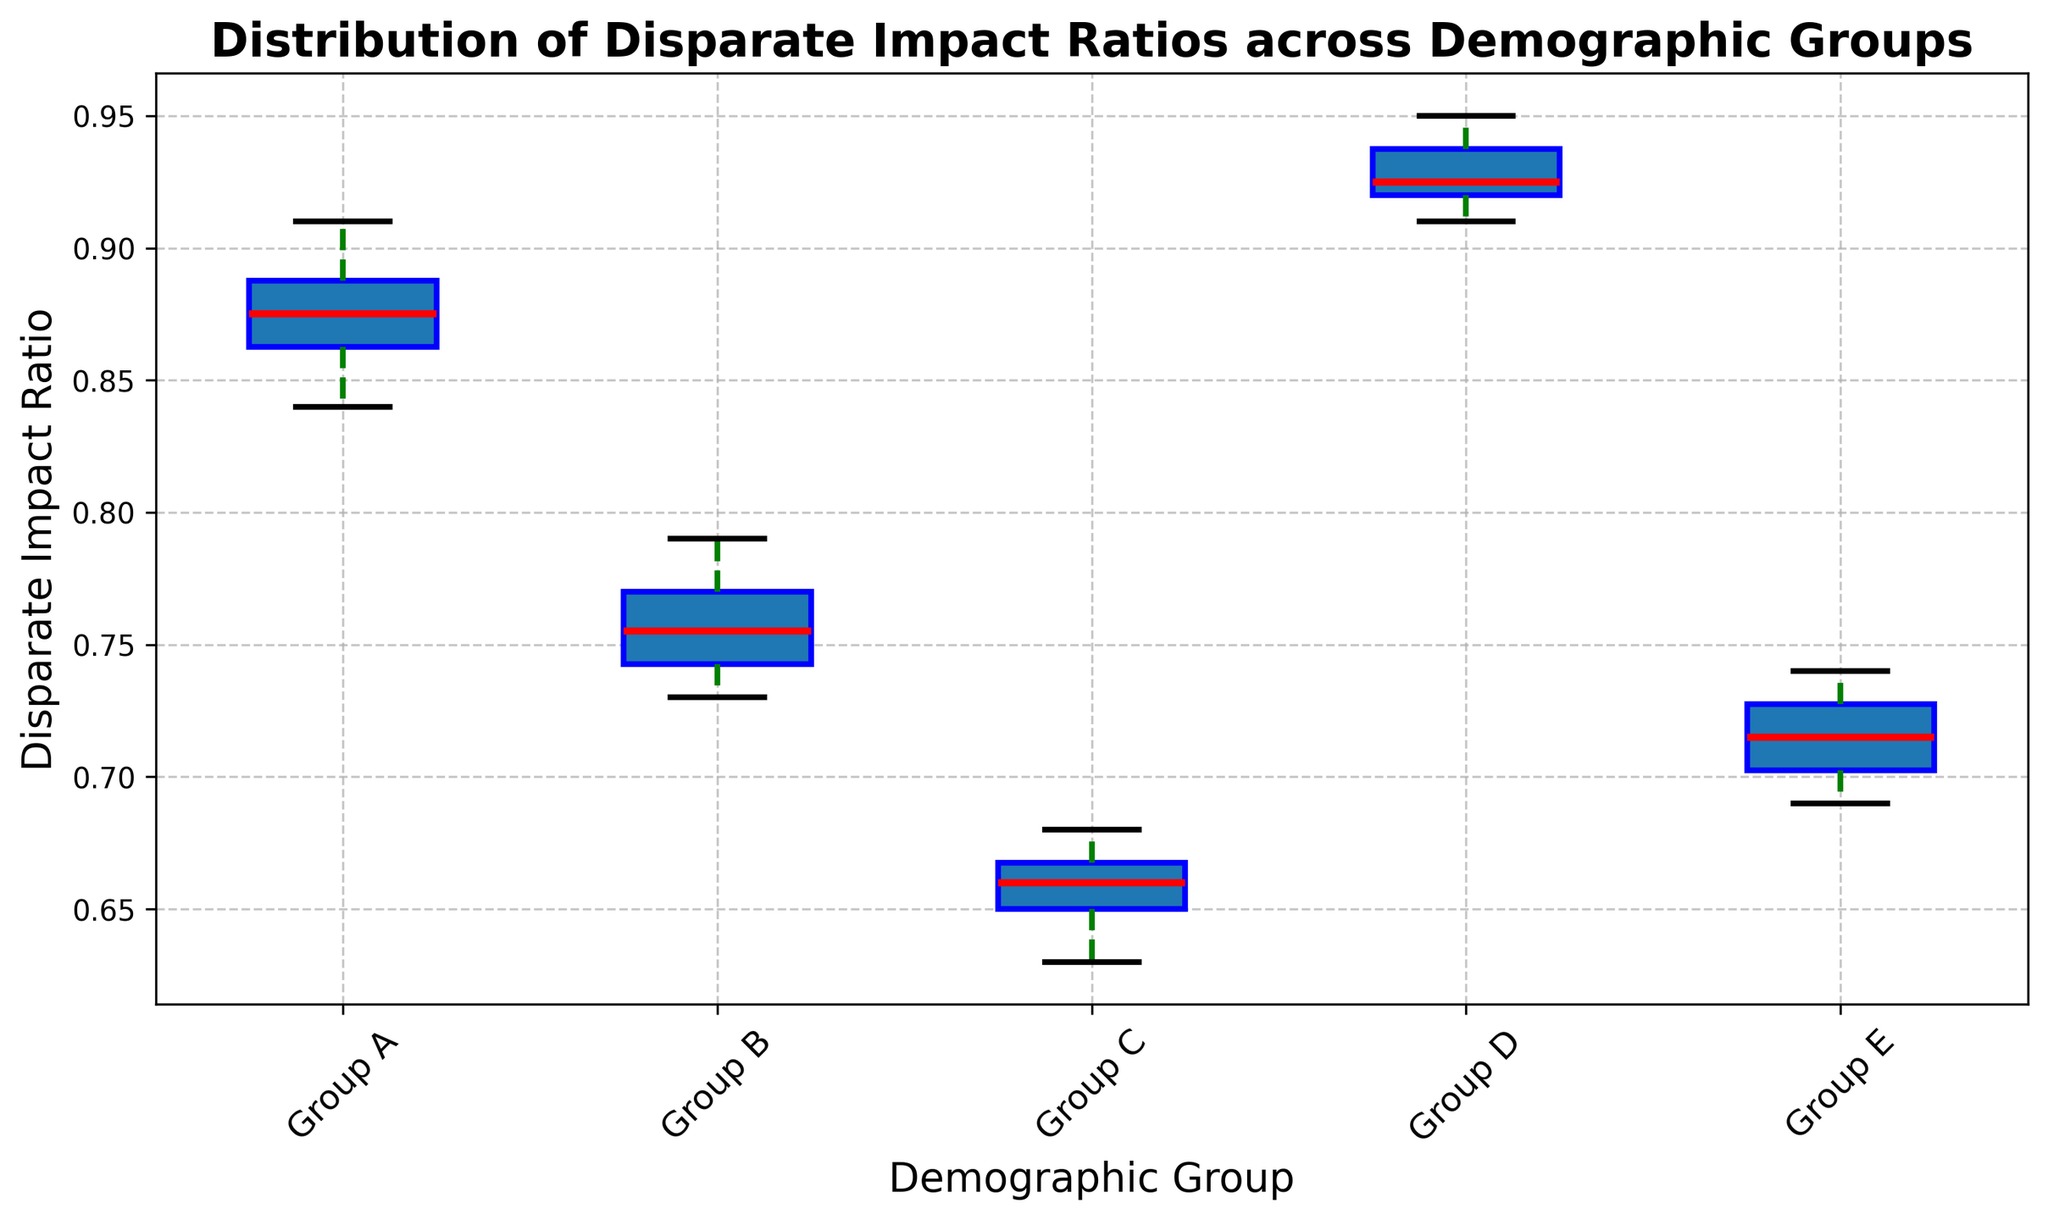What is the median Disparate Impact Ratio for Group A? The median is the middle value when the data is ordered. For Group A: 0.84, 0.85, 0.86, 0.87, 0.87, 0.88, 0.88, 0.89, 0.90, 0.91. The middle values are 0.87, 0.88, so the median is (0.87 + 0.88) / 2 = 0.875
Answer: 0.875 Which demographic group has the highest median Disparate Impact Ratio? To identify the highest median ratio, look at the median line inside each boxplot. Group D has the highest median Disparate Impact Ratio, visibly higher than all other groups.
Answer: Group D Between Group B and Group E, which group has a higher variance in their Disparate Impact Ratios? Variance refers to how spread out the ratios are. Group E has wider whiskers and a taller box, indicating more spread, thus higher variance compared to Group B.
Answer: Group E Are there any outliers in Group C's Disparate Impact Ratios? Outliers are typically represented by individual points beyond the whiskers. For Group C, there are no individual points outside the whiskers, hence no outliers.
Answer: No What is the interquartile range (IQR) for Group D? IQR is the difference between the third quartile (Q3) and the first quartile (Q1). In the boxplot, Q3 is the top of the box, and Q1 is the bottom of the box. For Group D, if Q3 = 0.94 and Q1 = 0.91, then IQR = 0.94 - 0.91 = 0.03
Answer: 0.03 How do the median Disparate Impact Ratios of Group A and Group B compare? The median is shown by the line inside the box. Group A has a median around 0.875, while Group B has a median significantly lower, around 0.75. Group A has a higher median.
Answer: Group A has a higher median How does the spread of Disparate Impact Ratios in Group E compare to that in Group C? Spread can be observed by the height of the boxes and the length of the whiskers. Group E has a taller box with slightly longer whiskers than Group C, indicating higher spread or variability.
Answer: Group E has a higher spread Which group shows the least variability in their Disparate Impact Ratios? The group with the shortest box and smallest whiskers will have the least variability. Group D has the smallest box and whiskers, indicating the least variability.
Answer: Group D 